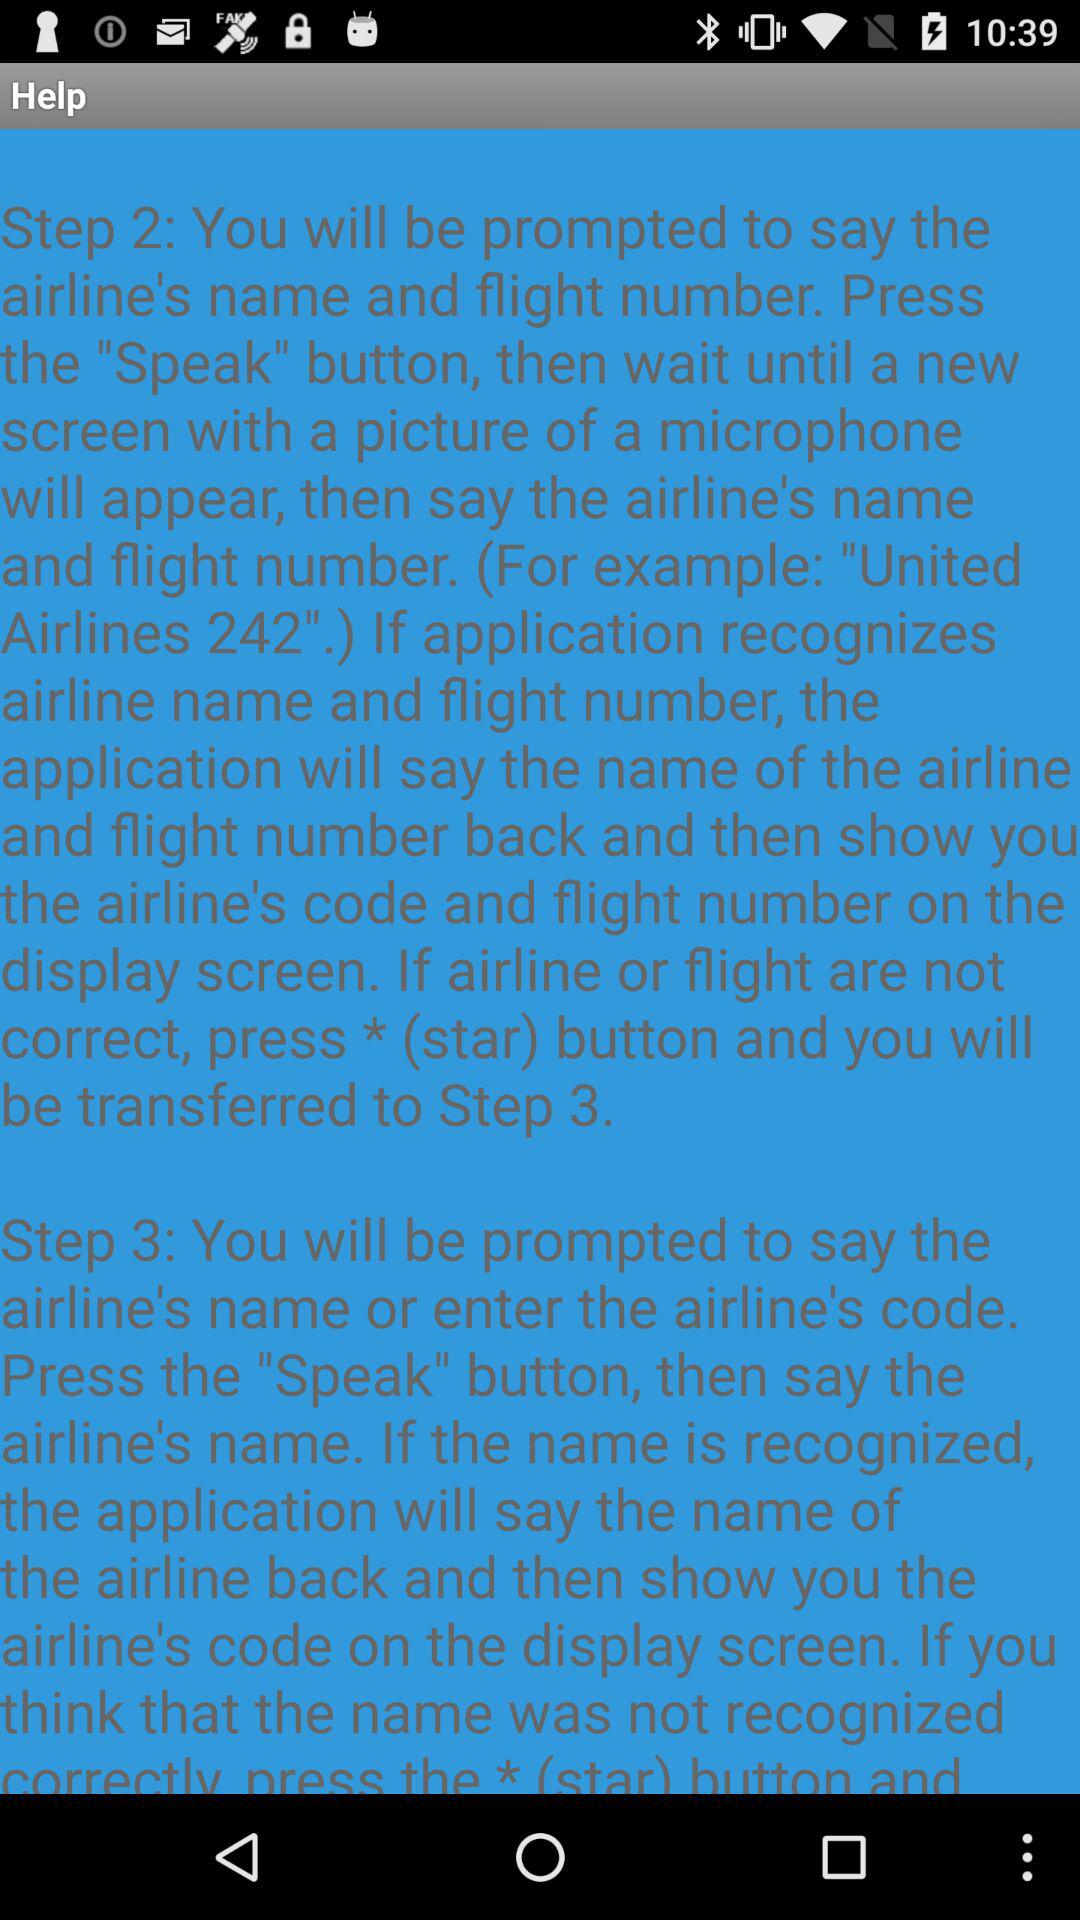How many steps are there in the instructions?
Answer the question using a single word or phrase. 3 